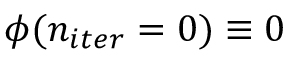<formula> <loc_0><loc_0><loc_500><loc_500>\phi ( n _ { i t e r } = 0 ) \equiv 0</formula> 